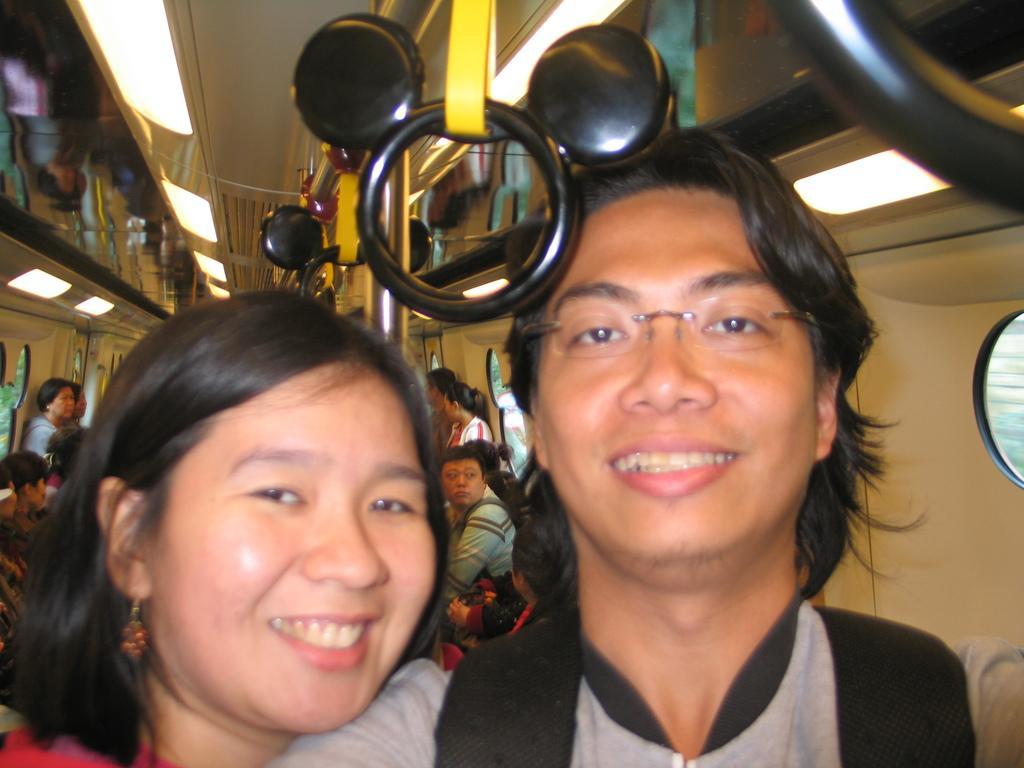Please provide a concise description of this image. In this image, we can see few people inside a vehicle. 